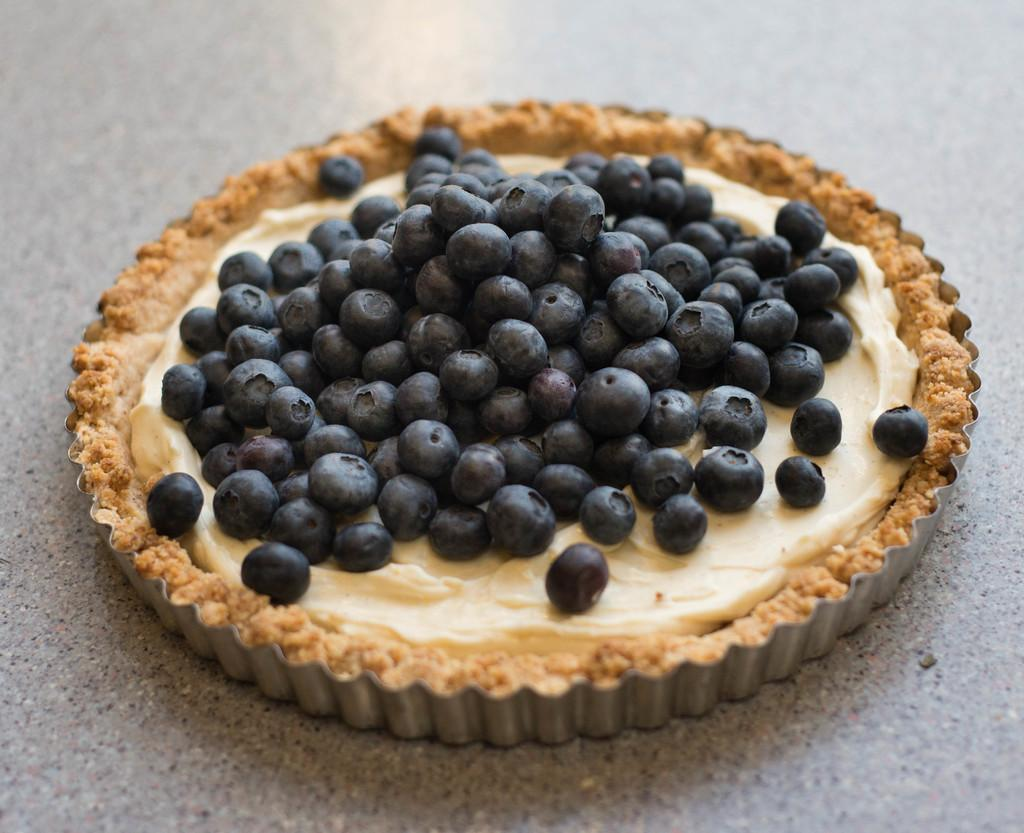What is the main food item in the image? There is a pancake in the image. What is placed on top of the pancake? There are black grapes on the pancake. Where is the pancake located? The pancake is on the floor. What type of knee can be seen supporting the pancake in the image? There is no knee present in the image; the pancake is on the floor. 